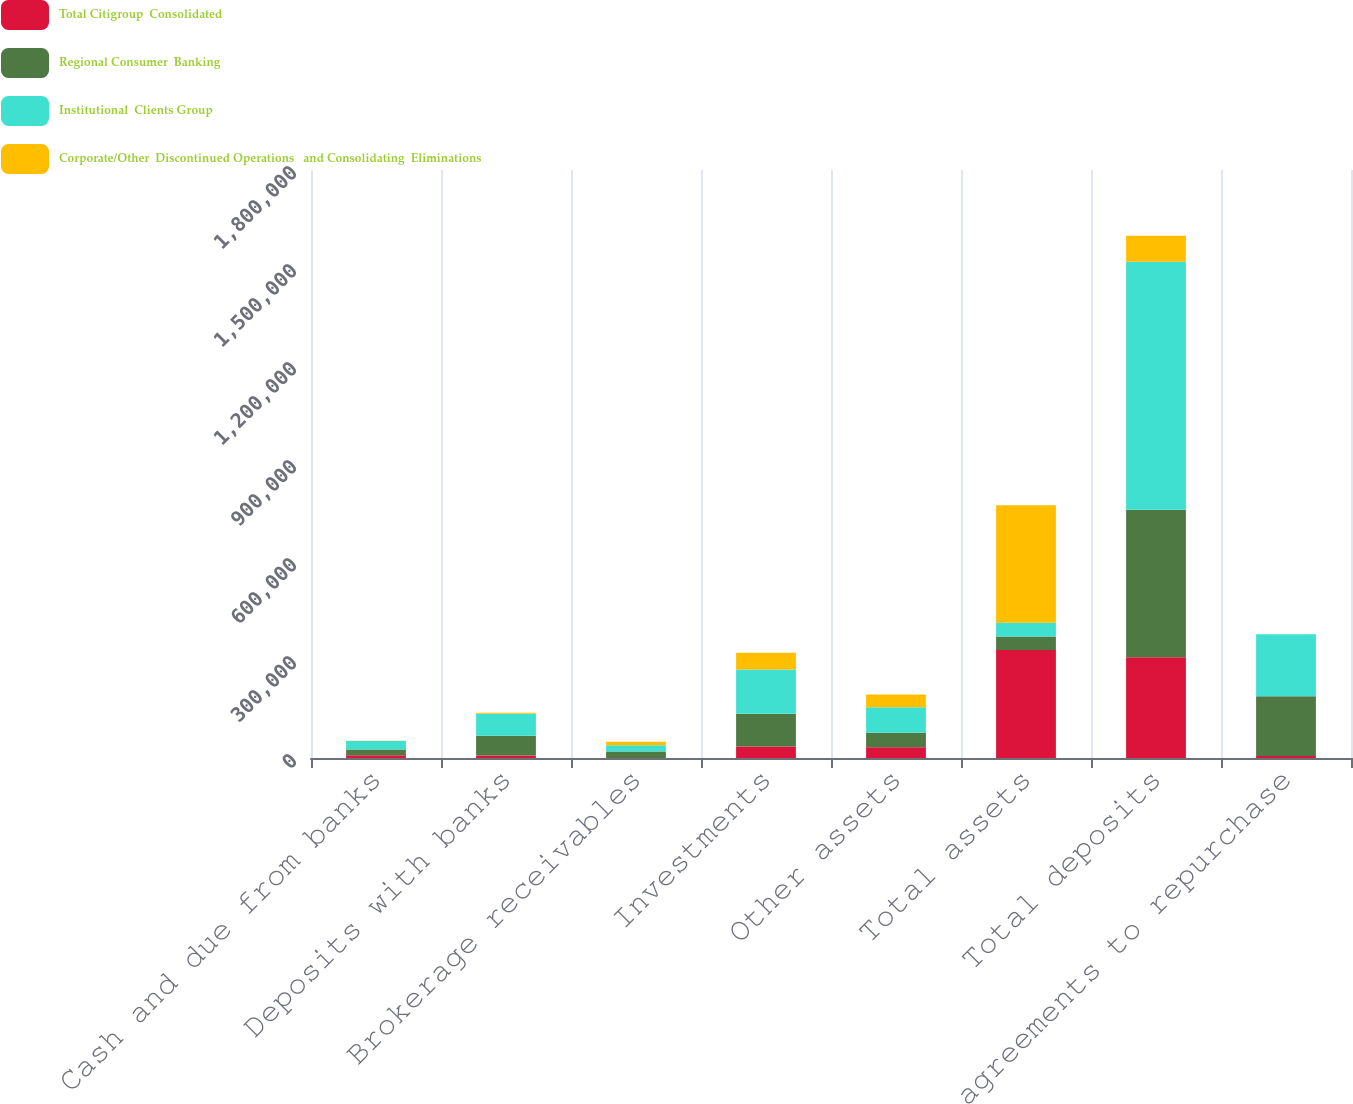Convert chart to OTSL. <chart><loc_0><loc_0><loc_500><loc_500><stacked_bar_chart><ecel><fcel>Cash and due from banks<fcel>Deposits with banks<fcel>Brokerage receivables<fcel>Investments<fcel>Other assets<fcel>Total assets<fcel>Total deposits<fcel>agreements to repurchase<nl><fcel>Total Citigroup  Consolidated<fcel>8576<fcel>7617<fcel>218<fcel>35472<fcel>32953<fcel>330279<fcel>308538<fcel>5776<nl><fcel>Regional Consumer  Banking<fcel>17259<fcel>60139<fcel>19316<fcel>99977<fcel>44609<fcel>41948<fcel>451192<fcel>183464<nl><fcel>Institutional  Clients Group<fcel>25835<fcel>67756<fcel>19534<fcel>135449<fcel>77562<fcel>41948<fcel>759730<fcel>189240<nl><fcel>Corporate/Other  Discontinued Operations   and Consolidating  Eliminations<fcel>1164<fcel>3204<fcel>10803<fcel>51263<fcel>39287<fcel>359192<fcel>79248<fcel>176<nl></chart> 